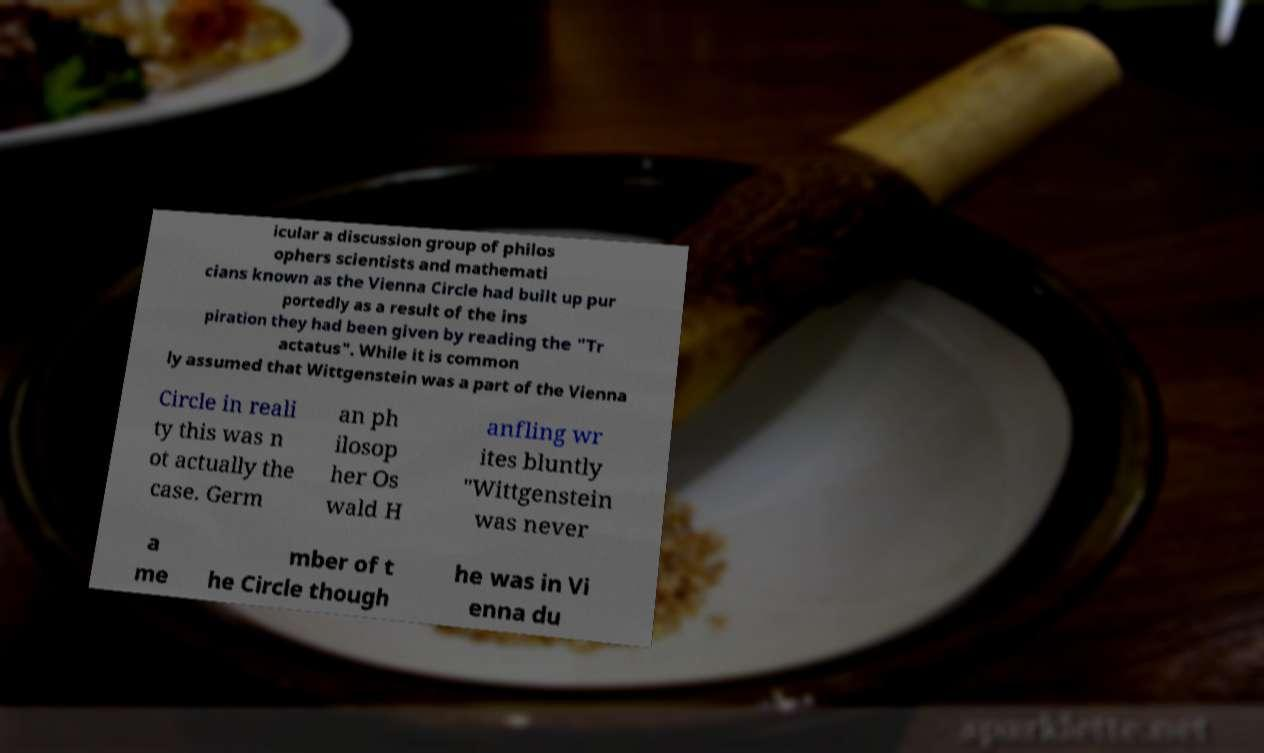Could you assist in decoding the text presented in this image and type it out clearly? icular a discussion group of philos ophers scientists and mathemati cians known as the Vienna Circle had built up pur portedly as a result of the ins piration they had been given by reading the "Tr actatus". While it is common ly assumed that Wittgenstein was a part of the Vienna Circle in reali ty this was n ot actually the case. Germ an ph ilosop her Os wald H anfling wr ites bluntly "Wittgenstein was never a me mber of t he Circle though he was in Vi enna du 